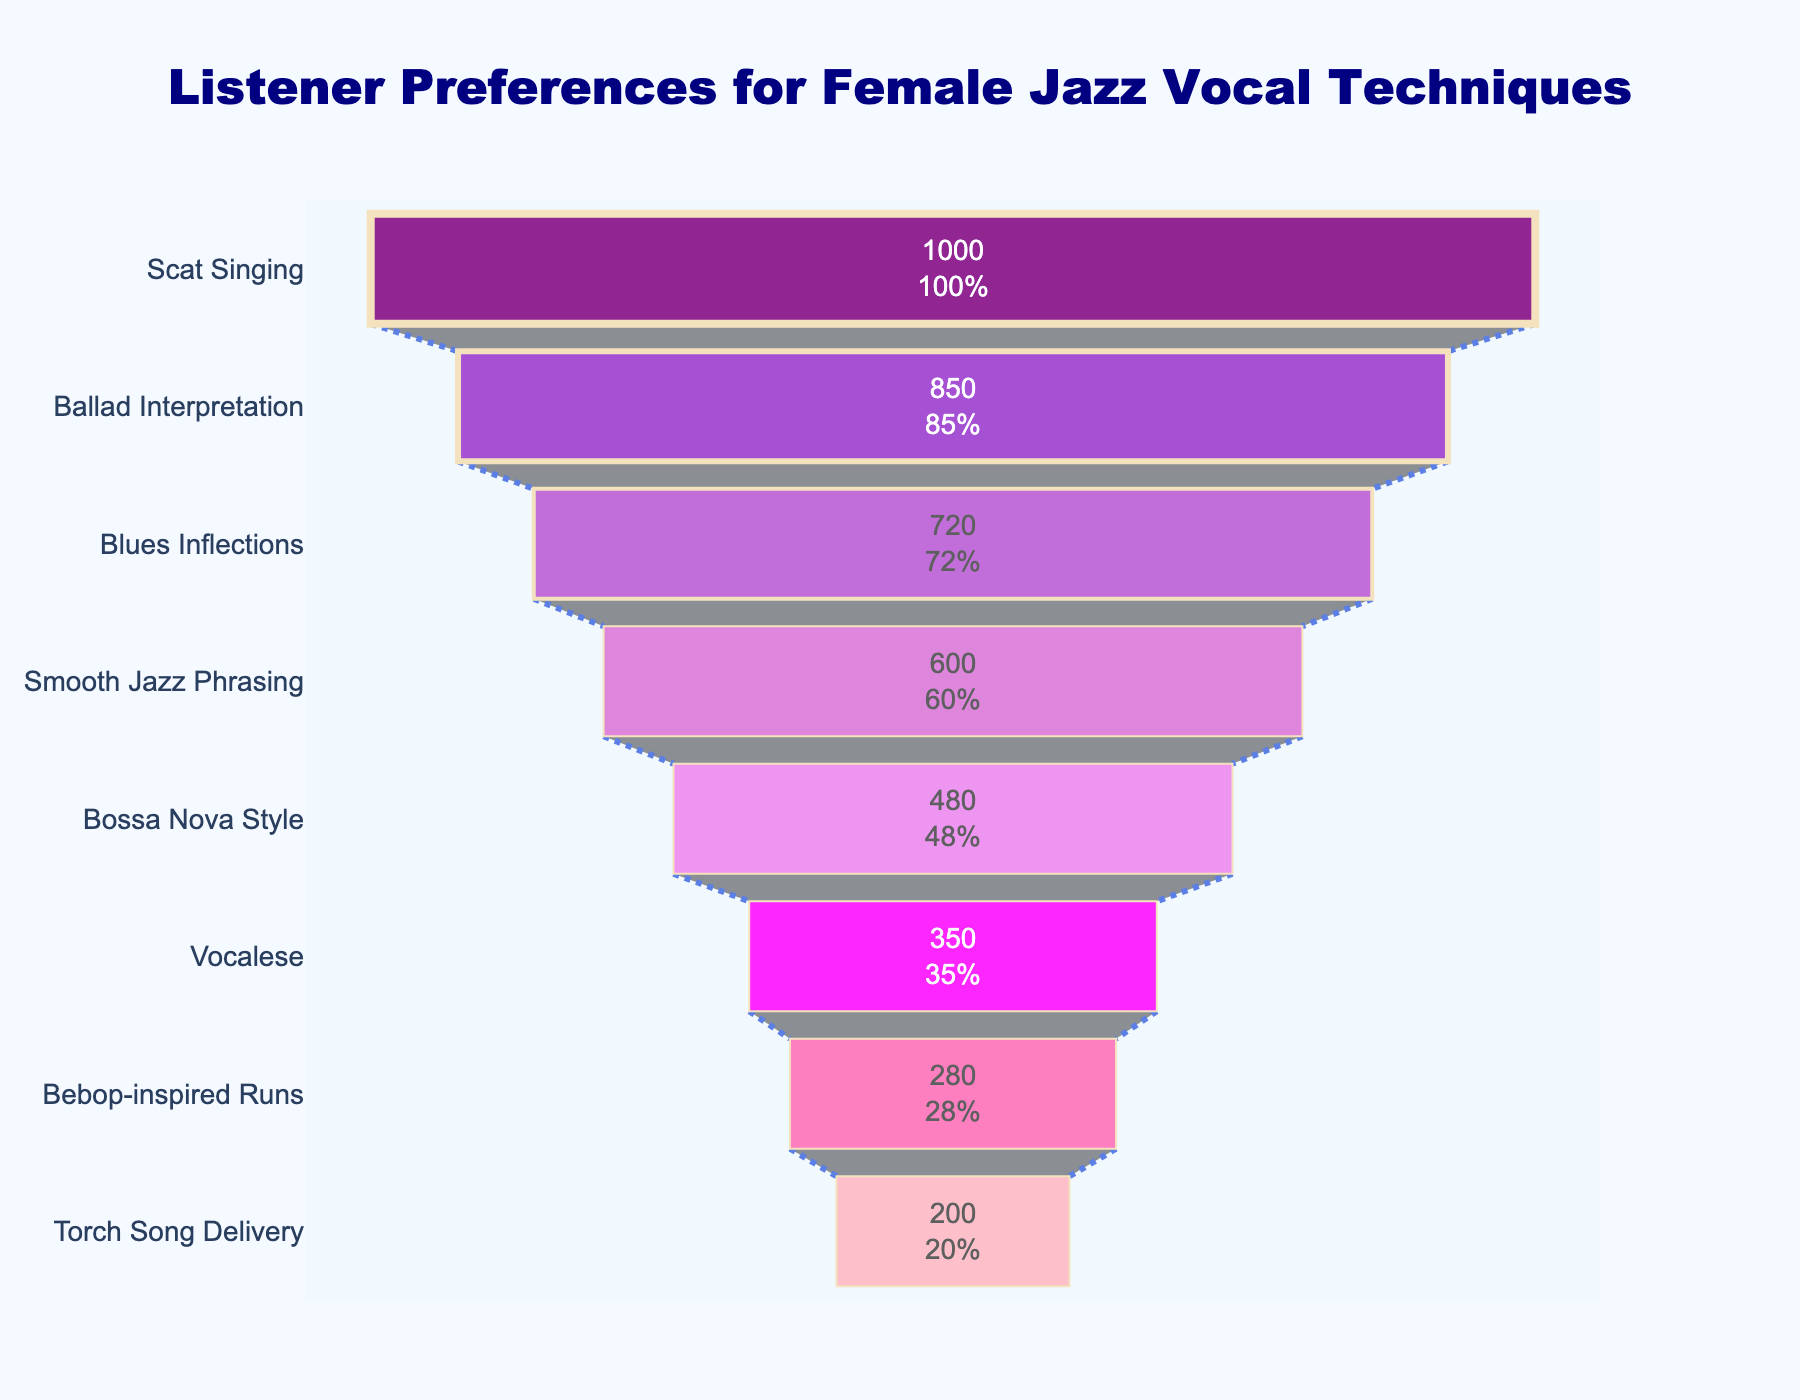What is the title of the figure? The title is usually displayed at the top of the figure in a larger and more prominent font size or style. In this figure, it reads "Listener Preferences for Female Jazz Vocal Techniques".
Answer: Listener Preferences for Female Jazz Vocal Techniques Which vocal technique is preferred by the most listeners? To identify this, look at the top segment of the funnel since it represents the largest value. The top segment is "Scat Singing".
Answer: Scat Singing How many listeners prefer Ballad Interpretation? Identify the segment labeled "Ballad Interpretation" and read the value inside it, which is numerically represented.
Answer: 850 Which vocal technique has the least number of listeners? Look at the bottom segment of the funnel to find the vocal technique with the smallest number. This is "Torch Song Delivery" with 200 listeners.
Answer: Torch Song Delivery What's the difference in listener preference between Scat Singing and Bebop-inspired Runs? Find the values for both vocal techniques from the funnel, Scat Singing has 1000 listeners and Bebop-inspired Runs has 280 listeners. Subtract the smaller number from the larger one: 1000 - 280.
Answer: 720 How many more listeners prefer Smooth Jazz Phrasing over Vocalese? Find the values for both vocal techniques. Smooth Jazz Phrasing has 600 listeners, and Vocalese has 350 listeners. Subtract the values: 600 - 350.
Answer: 250 What percentage of the total initial listeners prefer Bossa Nova Style? Determine the total initial number of listeners, which is the value at the top of the funnel (1000). The value for Bossa Nova Style is 480. The percentage is calculated as (480 / 1000) * 100.
Answer: 48% Which vocal techniques have more than 500 listeners? Check the numerical values inside each segment and list those with a count greater than 500: Scat Singing (1000), Ballad Interpretation (850), Blues Inflections (720), Smooth Jazz Phrasing (600).
Answer: Scat Singing, Ballad Interpretation, Blues Inflections, Smooth Jazz Phrasing What is the combined number of listeners for Blues Inflections and Bebop-inspired Runs? Add the number of listeners for both vocal techniques: Blues Inflections (720) and Bebop-inspired Runs (280). The total is 720 + 280.
Answer: 1000 What color is used for the segment representing Ballad Interpretation? Identify the color associated with the Ballad Interpretation segment. It corresponds to the second segment from the top and is purple (#9932CC).
Answer: Purple 